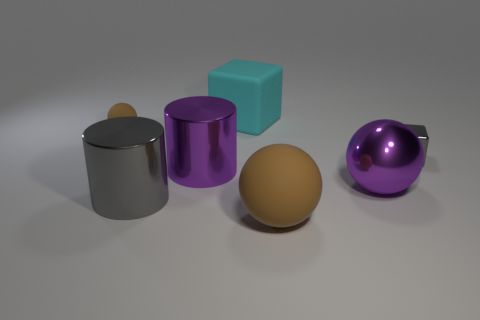Add 1 small gray metallic objects. How many objects exist? 8 Subtract all balls. How many objects are left? 4 Add 1 matte things. How many matte things exist? 4 Subtract 0 purple blocks. How many objects are left? 7 Subtract all tiny spheres. Subtract all large brown cylinders. How many objects are left? 6 Add 6 big purple things. How many big purple things are left? 8 